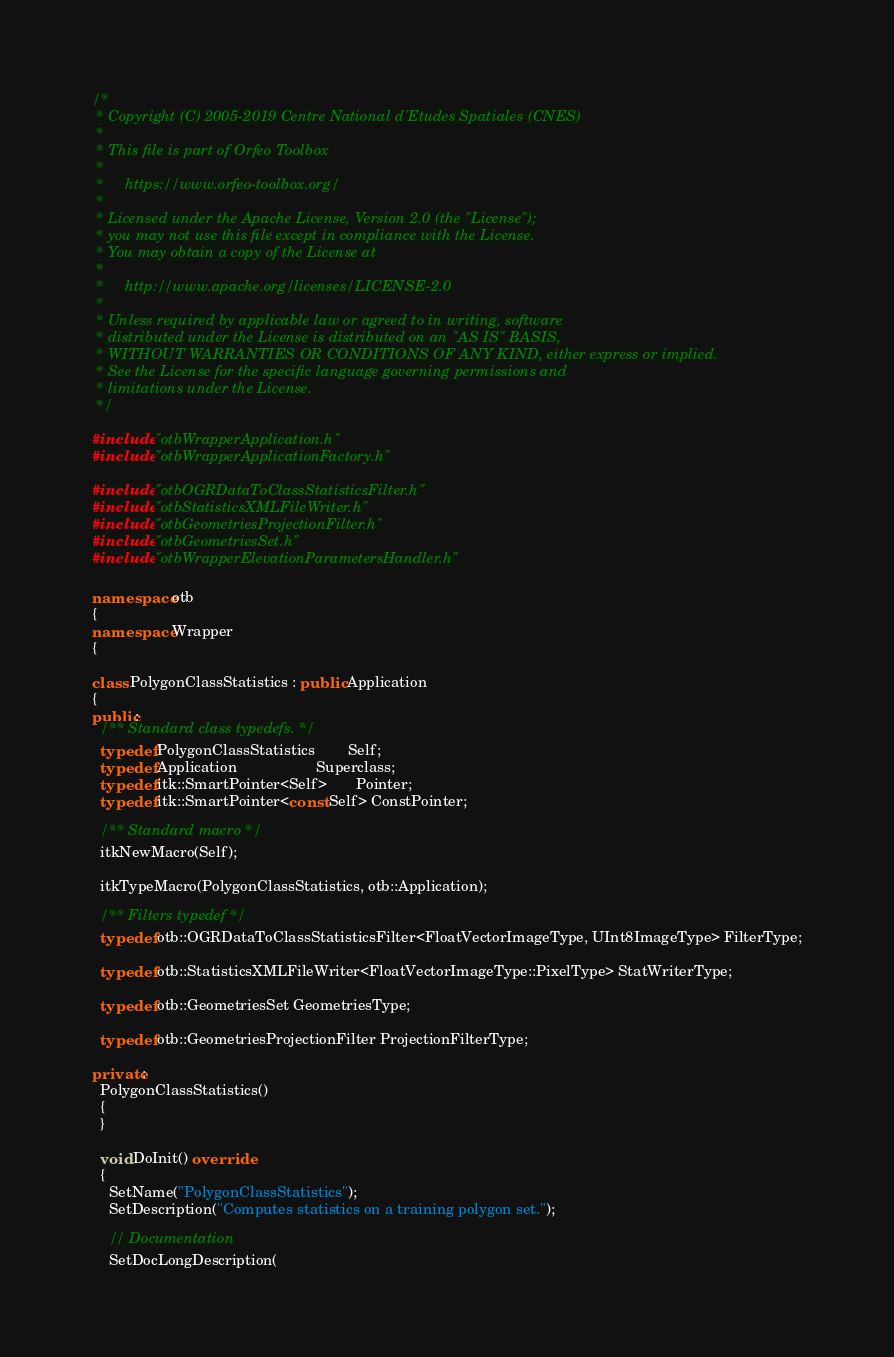<code> <loc_0><loc_0><loc_500><loc_500><_C++_>/*
 * Copyright (C) 2005-2019 Centre National d'Etudes Spatiales (CNES)
 *
 * This file is part of Orfeo Toolbox
 *
 *     https://www.orfeo-toolbox.org/
 *
 * Licensed under the Apache License, Version 2.0 (the "License");
 * you may not use this file except in compliance with the License.
 * You may obtain a copy of the License at
 *
 *     http://www.apache.org/licenses/LICENSE-2.0
 *
 * Unless required by applicable law or agreed to in writing, software
 * distributed under the License is distributed on an "AS IS" BASIS,
 * WITHOUT WARRANTIES OR CONDITIONS OF ANY KIND, either express or implied.
 * See the License for the specific language governing permissions and
 * limitations under the License.
 */

#include "otbWrapperApplication.h"
#include "otbWrapperApplicationFactory.h"

#include "otbOGRDataToClassStatisticsFilter.h"
#include "otbStatisticsXMLFileWriter.h"
#include "otbGeometriesProjectionFilter.h"
#include "otbGeometriesSet.h"
#include "otbWrapperElevationParametersHandler.h"

namespace otb
{
namespace Wrapper
{

class PolygonClassStatistics : public Application
{
public:
  /** Standard class typedefs. */
  typedef PolygonClassStatistics        Self;
  typedef Application                   Superclass;
  typedef itk::SmartPointer<Self>       Pointer;
  typedef itk::SmartPointer<const Self> ConstPointer;

  /** Standard macro */
  itkNewMacro(Self);

  itkTypeMacro(PolygonClassStatistics, otb::Application);

  /** Filters typedef */
  typedef otb::OGRDataToClassStatisticsFilter<FloatVectorImageType, UInt8ImageType> FilterType;

  typedef otb::StatisticsXMLFileWriter<FloatVectorImageType::PixelType> StatWriterType;

  typedef otb::GeometriesSet GeometriesType;

  typedef otb::GeometriesProjectionFilter ProjectionFilterType;

private:
  PolygonClassStatistics()
  {
  }

  void DoInit() override
  {
    SetName("PolygonClassStatistics");
    SetDescription("Computes statistics on a training polygon set.");

    // Documentation
    SetDocLongDescription(</code> 